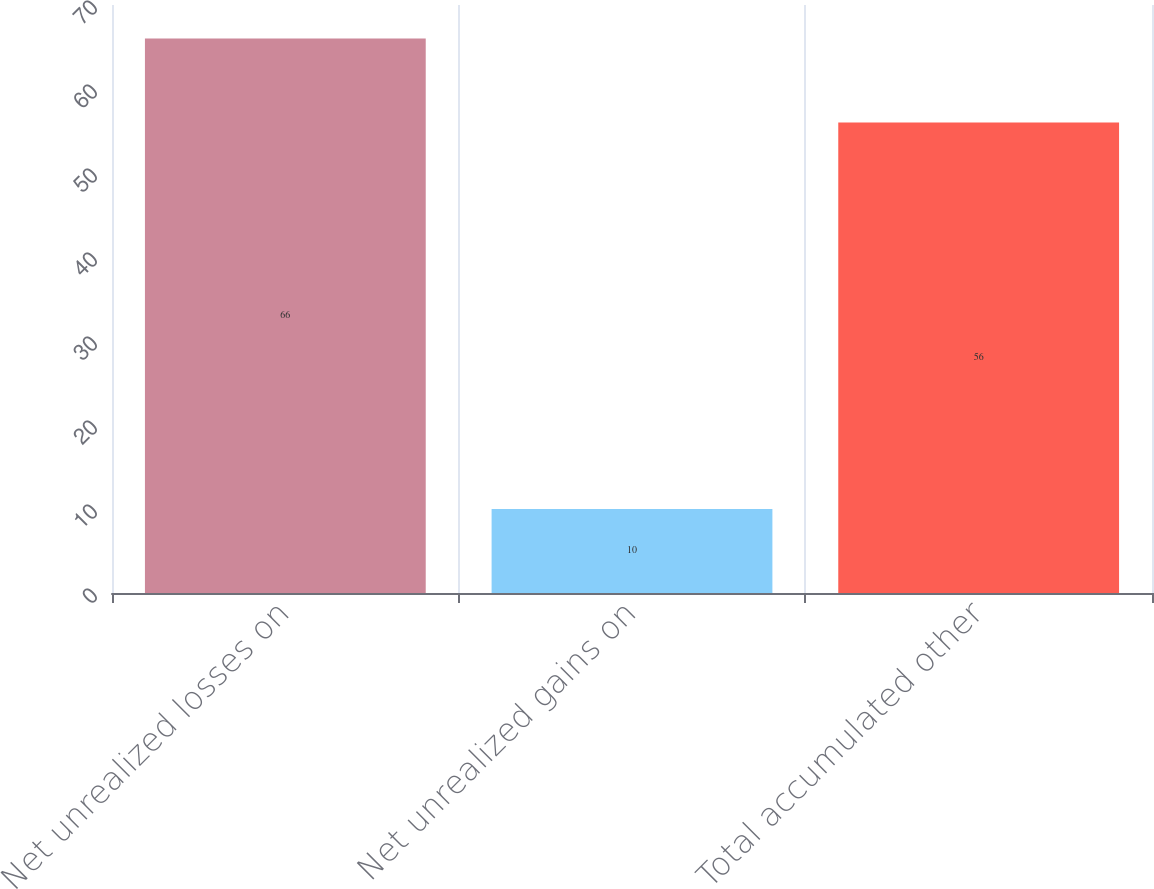Convert chart. <chart><loc_0><loc_0><loc_500><loc_500><bar_chart><fcel>Net unrealized losses on<fcel>Net unrealized gains on<fcel>Total accumulated other<nl><fcel>66<fcel>10<fcel>56<nl></chart> 